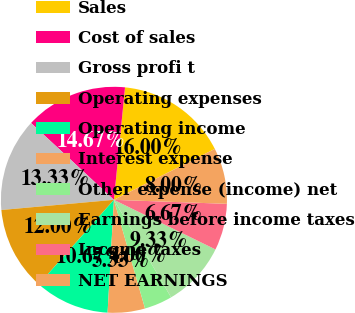Convert chart to OTSL. <chart><loc_0><loc_0><loc_500><loc_500><pie_chart><fcel>Sales<fcel>Cost of sales<fcel>Gross profi t<fcel>Operating expenses<fcel>Operating income<fcel>Interest expense<fcel>Other expense (income) net<fcel>Earnings before income taxes<fcel>Income taxes<fcel>NET EARNINGS<nl><fcel>16.0%<fcel>14.67%<fcel>13.33%<fcel>12.0%<fcel>10.67%<fcel>5.33%<fcel>4.0%<fcel>9.33%<fcel>6.67%<fcel>8.0%<nl></chart> 